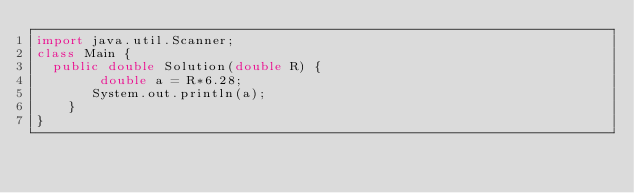<code> <loc_0><loc_0><loc_500><loc_500><_Java_>import java.util.Scanner;
class Main {
	public double Solution(double R) {
        double a = R*6.28;
       System.out.println(a);
    }
}</code> 